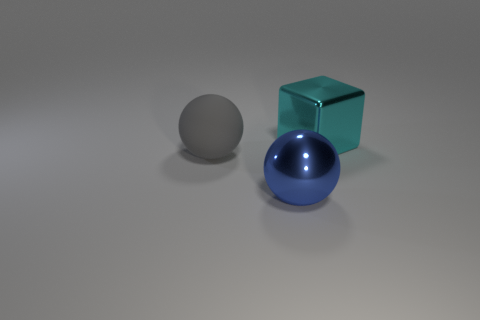Subtract all blue spheres. Subtract all gray cylinders. How many spheres are left? 1 Subtract all blue spheres. How many gray cubes are left? 0 Add 1 tiny blues. How many large objects exist? 0 Subtract all large cyan blocks. Subtract all tiny purple metal spheres. How many objects are left? 2 Add 3 big blue objects. How many big blue objects are left? 4 Add 1 blue metal spheres. How many blue metal spheres exist? 2 Add 2 large rubber things. How many objects exist? 5 Subtract all blue balls. How many balls are left? 1 Subtract 0 green balls. How many objects are left? 3 Subtract all blocks. How many objects are left? 2 